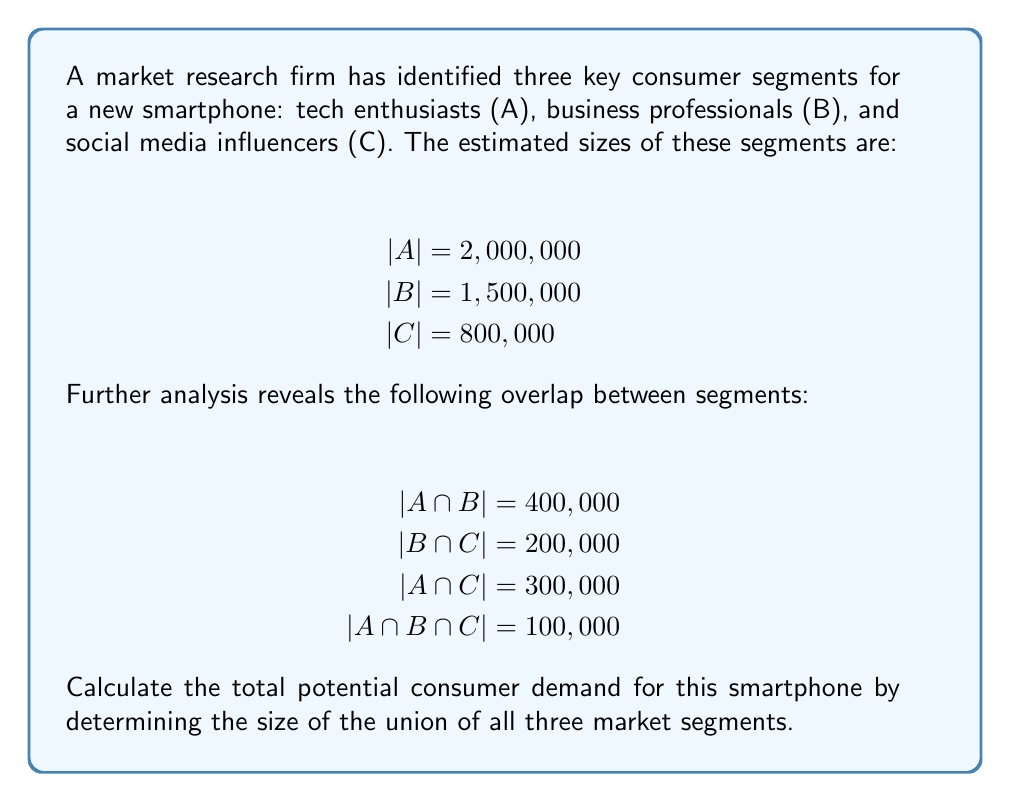Show me your answer to this math problem. To solve this problem, we'll use the Inclusion-Exclusion Principle for three sets:

$$|A \cup B \cup C| = |A| + |B| + |C| - |A \cap B| - |B \cap C| - |A \cap C| + |A \cap B \cap C|$$

Let's substitute the given values:

$$\begin{align*}
|A \cup B \cup C| &= 2,000,000 + 1,500,000 + 800,000 \\
&\quad - 400,000 - 200,000 - 300,000 \\
&\quad + 100,000
\end{align*}$$

Now, let's calculate:

$$\begin{align*}
|A \cup B \cup C| &= 4,300,000 - 900,000 + 100,000 \\
&= 3,500,000
\end{align*}$$

This result represents the total number of unique consumers across all three segments, accounting for overlaps. It provides an estimate of the total potential consumer demand for the smartphone.
Answer: The total potential consumer demand, represented by the union of all three market segments, is 3,500,000 consumers. 